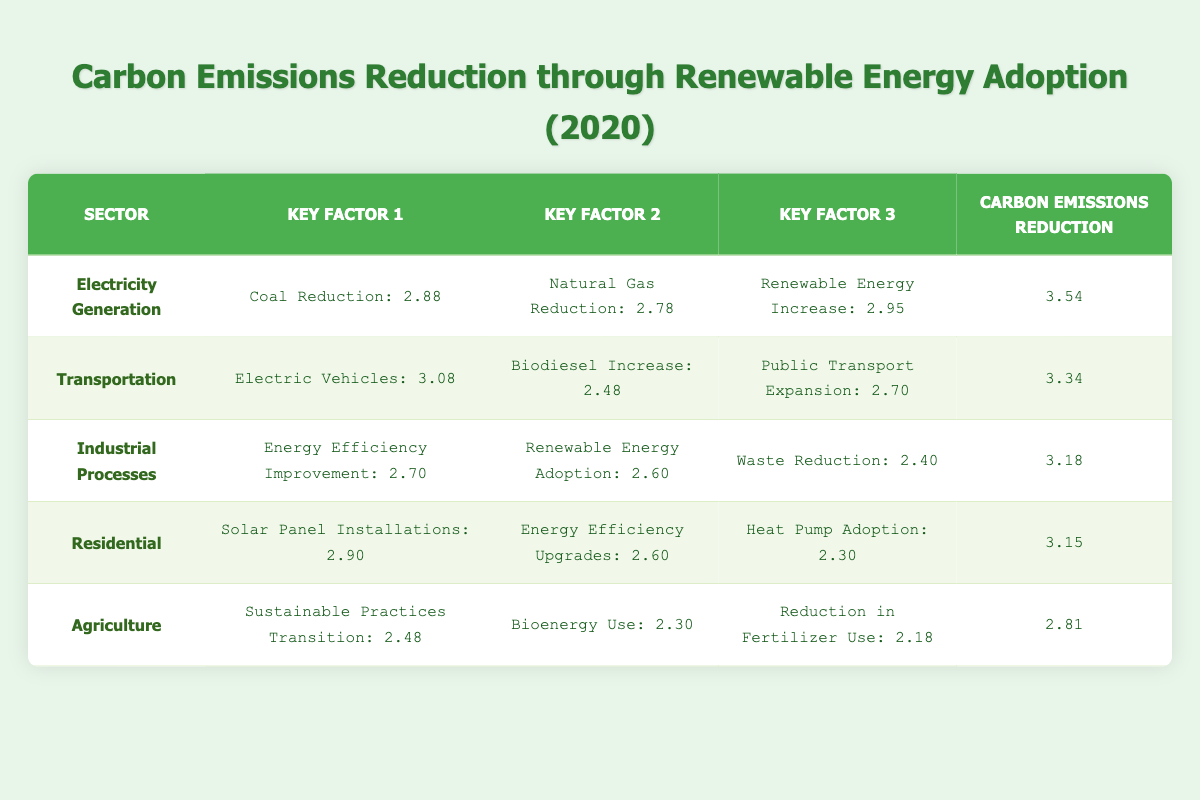What is the carbon emissions reduction in the Electricity Generation sector? The table shows that the carbon emissions reduction in the Electricity Generation sector is identified under the final column, which states 3.54.
Answer: 3.54 Which sector had the highest carbon emissions reduction? By comparing the carbon emissions reduction values across all sectors in the final column, it's clear that the Electricity Generation sector recorded the highest reduction at 3.54.
Answer: Electricity Generation What was the total carbon emissions reduction from the Transportation and Industrial Processes sectors? We first find the carbon emissions reduction for both sectors: Transportation has 3.34 and Industrial Processes has 3.18. Adding them together gives 3.34 + 3.18 = 6.52.
Answer: 6.52 Is the carbon emissions reduction from Agriculture greater than that from Residential? The carbon emissions reduction in Agriculture is 2.81 and in Residential is 3.15. Since 2.81 is less than 3.15, we conclude that the statement is false.
Answer: No What is the average carbon emissions reduction across all sectors? First, we calculate the total carbon emissions reduction by adding all the values: 3.54 + 3.34 + 3.18 + 3.15 + 2.81 = 15.02. There are 5 sectors, so we divide the total by 5 to get 15.02 / 5 = 3.004.
Answer: 3.004 Which key factor in the Transportation sector had the lowest logarithmic value? Looking at the key factors in the Transportation sector, the values are 3.08 for electric vehicles, 2.48 for biodiesel increase, and 2.70 for public transport expansion. The smallest value is 2.48 for biodiesel increase.
Answer: Biodiesel Increase How much more carbon emissions reduction occurred in the Electricity Generation sector compared to Agriculture? The reduction in Electricity Generation is 3.54, while in Agriculture it is 2.81. To find the difference, we subtract: 3.54 - 2.81 = 0.73.
Answer: 0.73 Did the Residential sector show greater carbon emissions reduction than the Industrial Processes sector? The Residential sector has 3.15 while the Industrial Processes sector has 3.18. Since 3.15 is less than 3.18, the statement is false.
Answer: No 